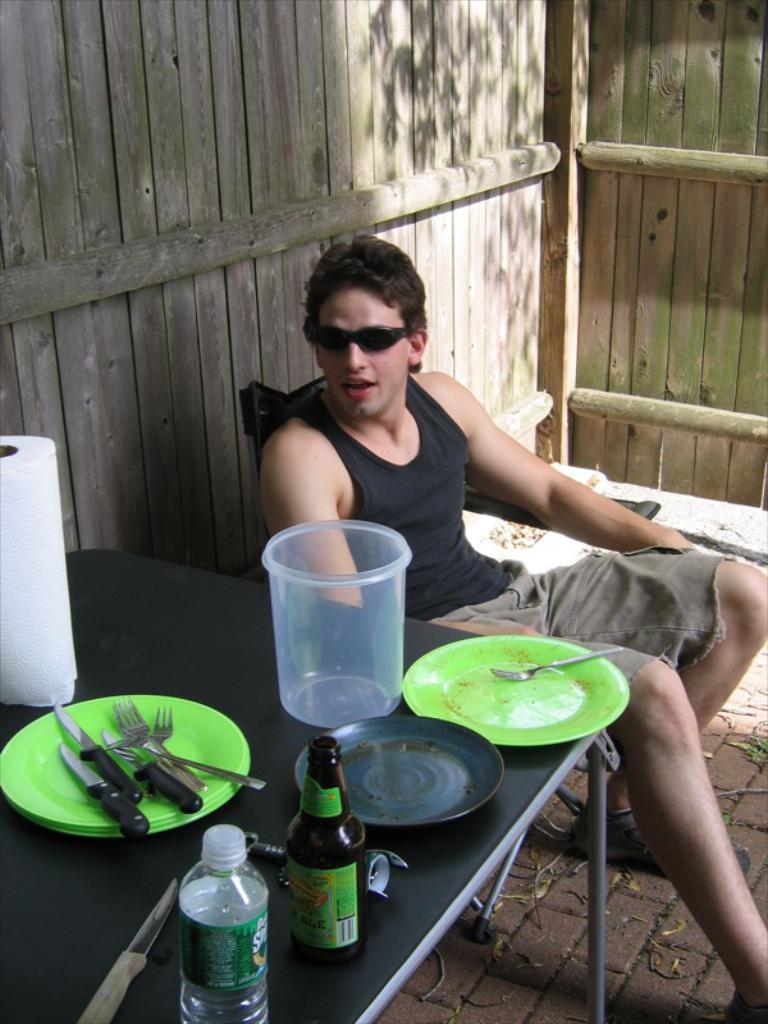Can you describe this image briefly? In this picture there is a man sitting on a chair. There is a bottle, knife, forks, plates, tissue roll , plastic vessel. There is a table. 